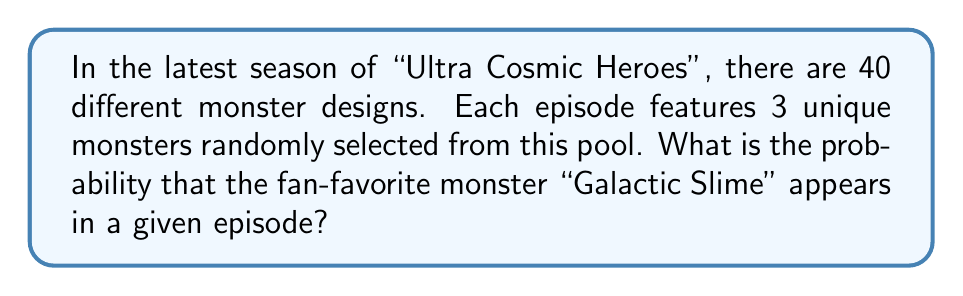Give your solution to this math problem. Let's approach this step-by-step:

1) First, we need to calculate the total number of possible combinations of 3 monsters from a pool of 40. This can be done using the combination formula:

   $$\binom{40}{3} = \frac{40!}{3!(40-3)!} = \frac{40!}{3!37!} = 9880$$

2) Now, we need to calculate the number of combinations that include Galactic Slime. To do this, we can:
   - Fix Galactic Slime as one of the monsters
   - Choose the other 2 monsters from the remaining 39

   This can be calculated as:

   $$\binom{39}{2} = \frac{39!}{2!(39-2)!} = \frac{39!}{2!37!} = 741$$

3) The probability is then the number of favorable outcomes divided by the total number of possible outcomes:

   $$P(\text{Galactic Slime appears}) = \frac{741}{9880}$$

4) Simplifying this fraction:

   $$\frac{741}{9880} = \frac{3}{40} = 0.075$$

Thus, the probability is 0.075 or 7.5%.
Answer: $\frac{3}{40}$ or 0.075 or 7.5% 